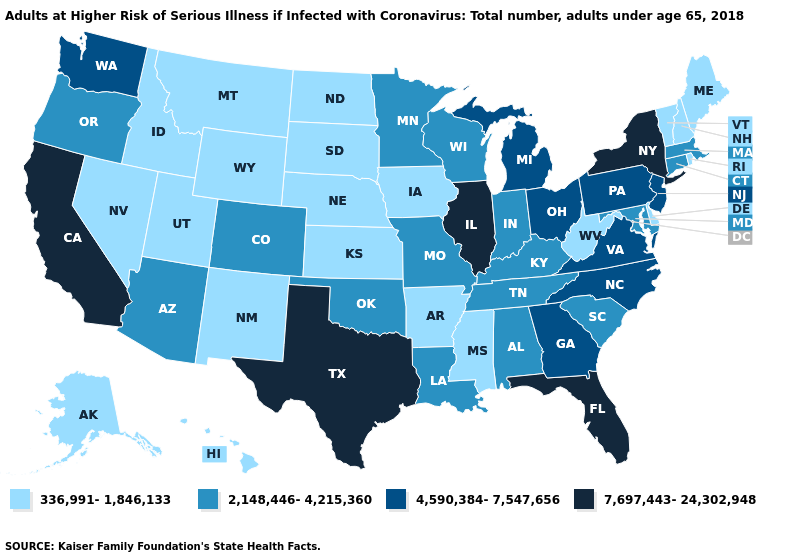What is the value of Louisiana?
Write a very short answer. 2,148,446-4,215,360. Does the first symbol in the legend represent the smallest category?
Be succinct. Yes. Name the states that have a value in the range 336,991-1,846,133?
Short answer required. Alaska, Arkansas, Delaware, Hawaii, Idaho, Iowa, Kansas, Maine, Mississippi, Montana, Nebraska, Nevada, New Hampshire, New Mexico, North Dakota, Rhode Island, South Dakota, Utah, Vermont, West Virginia, Wyoming. What is the value of South Carolina?
Be succinct. 2,148,446-4,215,360. What is the value of Oklahoma?
Short answer required. 2,148,446-4,215,360. Does the map have missing data?
Write a very short answer. No. Does Utah have a lower value than Delaware?
Answer briefly. No. Among the states that border West Virginia , does Pennsylvania have the lowest value?
Keep it brief. No. Name the states that have a value in the range 2,148,446-4,215,360?
Write a very short answer. Alabama, Arizona, Colorado, Connecticut, Indiana, Kentucky, Louisiana, Maryland, Massachusetts, Minnesota, Missouri, Oklahoma, Oregon, South Carolina, Tennessee, Wisconsin. Among the states that border North Dakota , does Minnesota have the highest value?
Be succinct. Yes. Is the legend a continuous bar?
Concise answer only. No. Name the states that have a value in the range 2,148,446-4,215,360?
Write a very short answer. Alabama, Arizona, Colorado, Connecticut, Indiana, Kentucky, Louisiana, Maryland, Massachusetts, Minnesota, Missouri, Oklahoma, Oregon, South Carolina, Tennessee, Wisconsin. Does South Carolina have the lowest value in the USA?
Quick response, please. No. Name the states that have a value in the range 4,590,384-7,547,656?
Write a very short answer. Georgia, Michigan, New Jersey, North Carolina, Ohio, Pennsylvania, Virginia, Washington. Does Michigan have a higher value than Illinois?
Short answer required. No. 